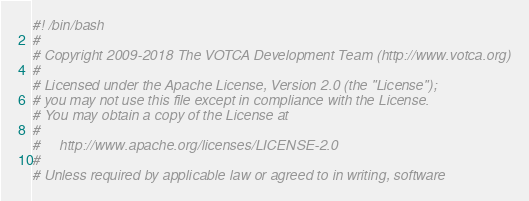Convert code to text. <code><loc_0><loc_0><loc_500><loc_500><_Bash_>#! /bin/bash
#
# Copyright 2009-2018 The VOTCA Development Team (http://www.votca.org)
#
# Licensed under the Apache License, Version 2.0 (the "License");
# you may not use this file except in compliance with the License.
# You may obtain a copy of the License at
#
#     http://www.apache.org/licenses/LICENSE-2.0
#
# Unless required by applicable law or agreed to in writing, software</code> 